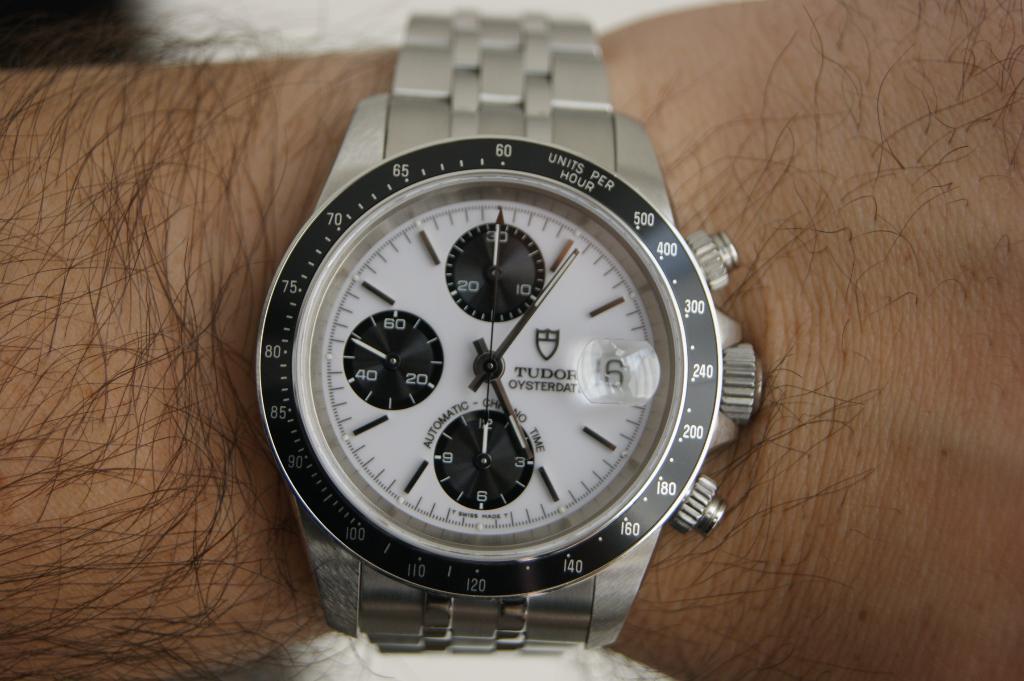What sea creature's name is found on this watch?
Your answer should be compact. Oyster. What brand of watch is this?
Offer a very short reply. Tudor. 